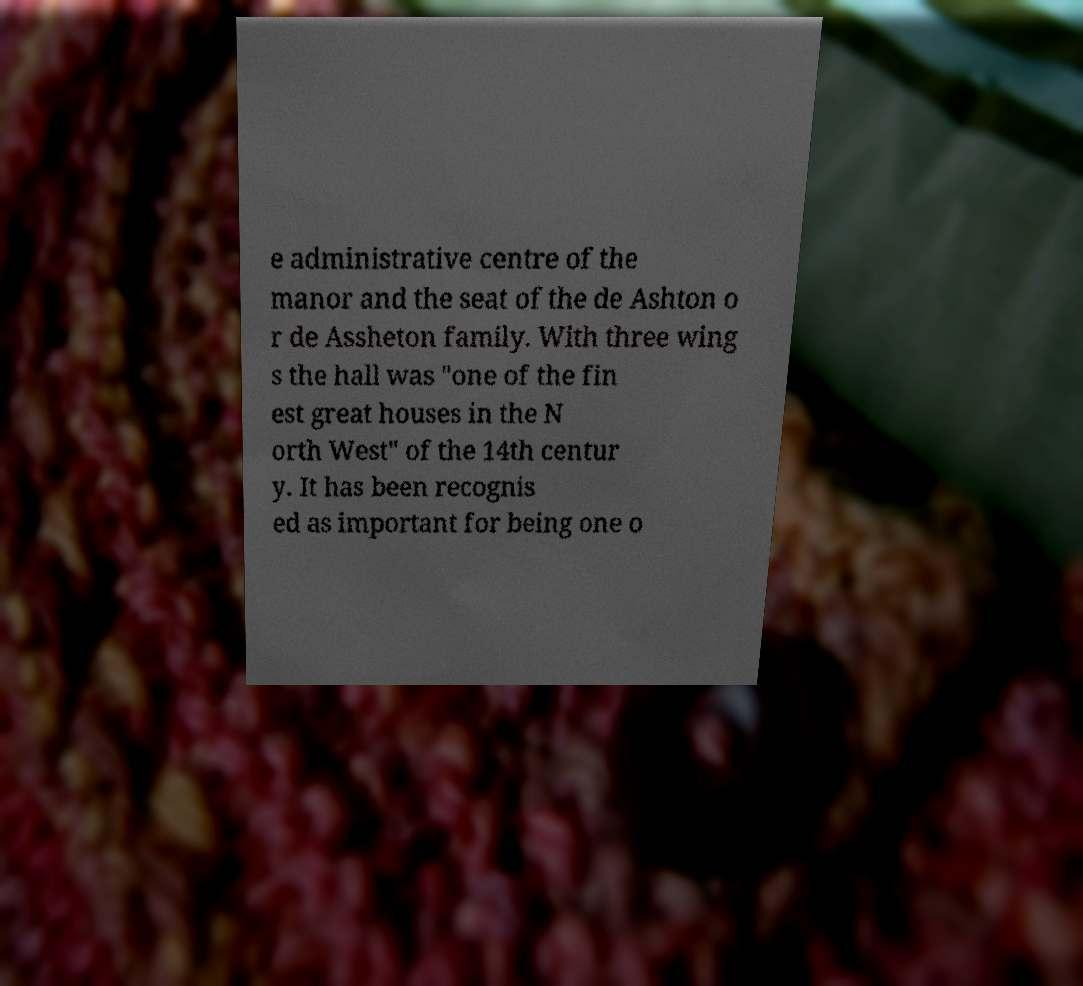Please identify and transcribe the text found in this image. e administrative centre of the manor and the seat of the de Ashton o r de Assheton family. With three wing s the hall was "one of the fin est great houses in the N orth West" of the 14th centur y. It has been recognis ed as important for being one o 